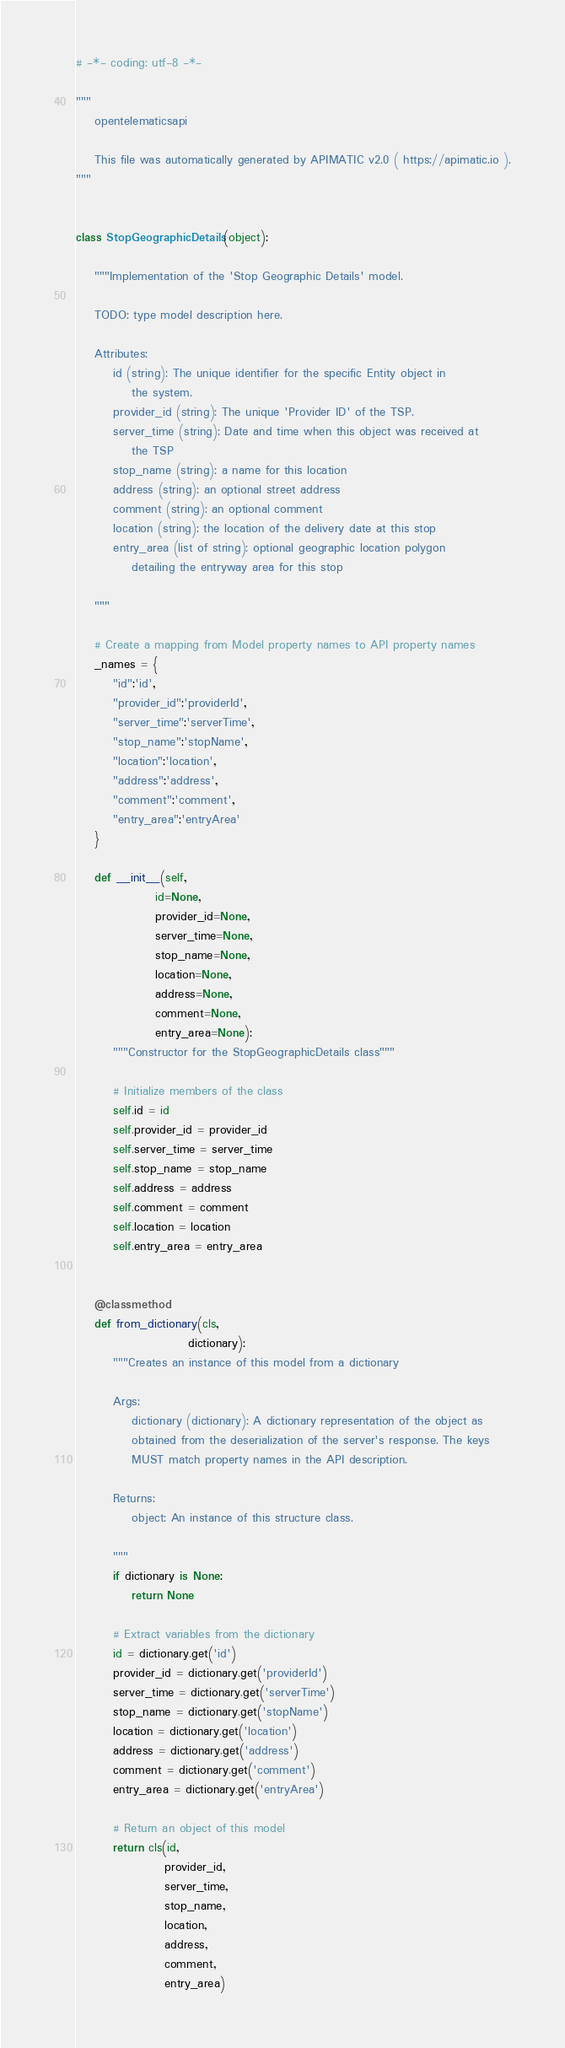Convert code to text. <code><loc_0><loc_0><loc_500><loc_500><_Python_># -*- coding: utf-8 -*-

"""
    opentelematicsapi

    This file was automatically generated by APIMATIC v2.0 ( https://apimatic.io ).
"""


class StopGeographicDetails(object):

    """Implementation of the 'Stop Geographic Details' model.

    TODO: type model description here.

    Attributes:
        id (string): The unique identifier for the specific Entity object in
            the system.
        provider_id (string): The unique 'Provider ID' of the TSP.
        server_time (string): Date and time when this object was received at
            the TSP
        stop_name (string): a name for this location
        address (string): an optional street address
        comment (string): an optional comment
        location (string): the location of the delivery date at this stop
        entry_area (list of string): optional geographic location polygon
            detailing the entryway area for this stop

    """

    # Create a mapping from Model property names to API property names
    _names = {
        "id":'id',
        "provider_id":'providerId',
        "server_time":'serverTime',
        "stop_name":'stopName',
        "location":'location',
        "address":'address',
        "comment":'comment',
        "entry_area":'entryArea'
    }

    def __init__(self,
                 id=None,
                 provider_id=None,
                 server_time=None,
                 stop_name=None,
                 location=None,
                 address=None,
                 comment=None,
                 entry_area=None):
        """Constructor for the StopGeographicDetails class"""

        # Initialize members of the class
        self.id = id
        self.provider_id = provider_id
        self.server_time = server_time
        self.stop_name = stop_name
        self.address = address
        self.comment = comment
        self.location = location
        self.entry_area = entry_area


    @classmethod
    def from_dictionary(cls,
                        dictionary):
        """Creates an instance of this model from a dictionary

        Args:
            dictionary (dictionary): A dictionary representation of the object as
            obtained from the deserialization of the server's response. The keys
            MUST match property names in the API description.

        Returns:
            object: An instance of this structure class.

        """
        if dictionary is None:
            return None

        # Extract variables from the dictionary
        id = dictionary.get('id')
        provider_id = dictionary.get('providerId')
        server_time = dictionary.get('serverTime')
        stop_name = dictionary.get('stopName')
        location = dictionary.get('location')
        address = dictionary.get('address')
        comment = dictionary.get('comment')
        entry_area = dictionary.get('entryArea')

        # Return an object of this model
        return cls(id,
                   provider_id,
                   server_time,
                   stop_name,
                   location,
                   address,
                   comment,
                   entry_area)


</code> 